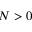<formula> <loc_0><loc_0><loc_500><loc_500>N > 0</formula> 